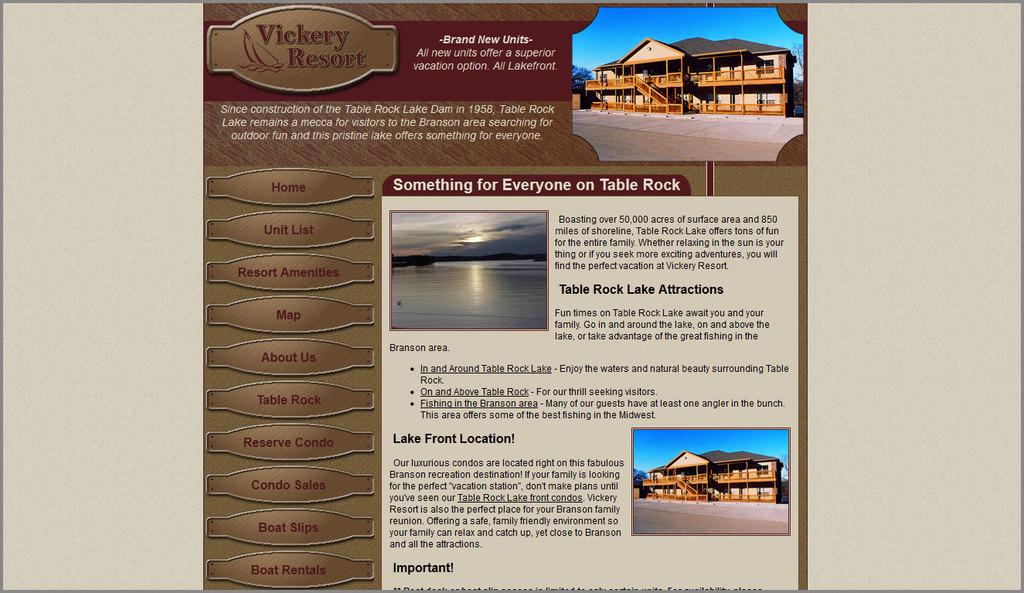<image>
Share a concise interpretation of the image provided. A web page shows the attractions at the Vickery Resort. 